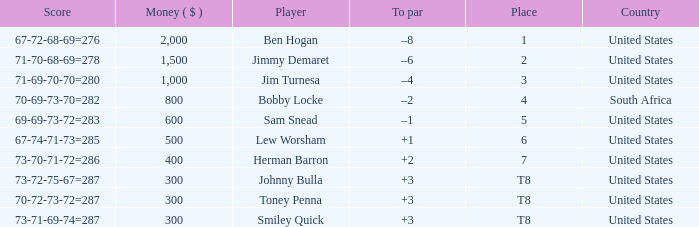What is the Money of the Player in Place 5? 600.0. 